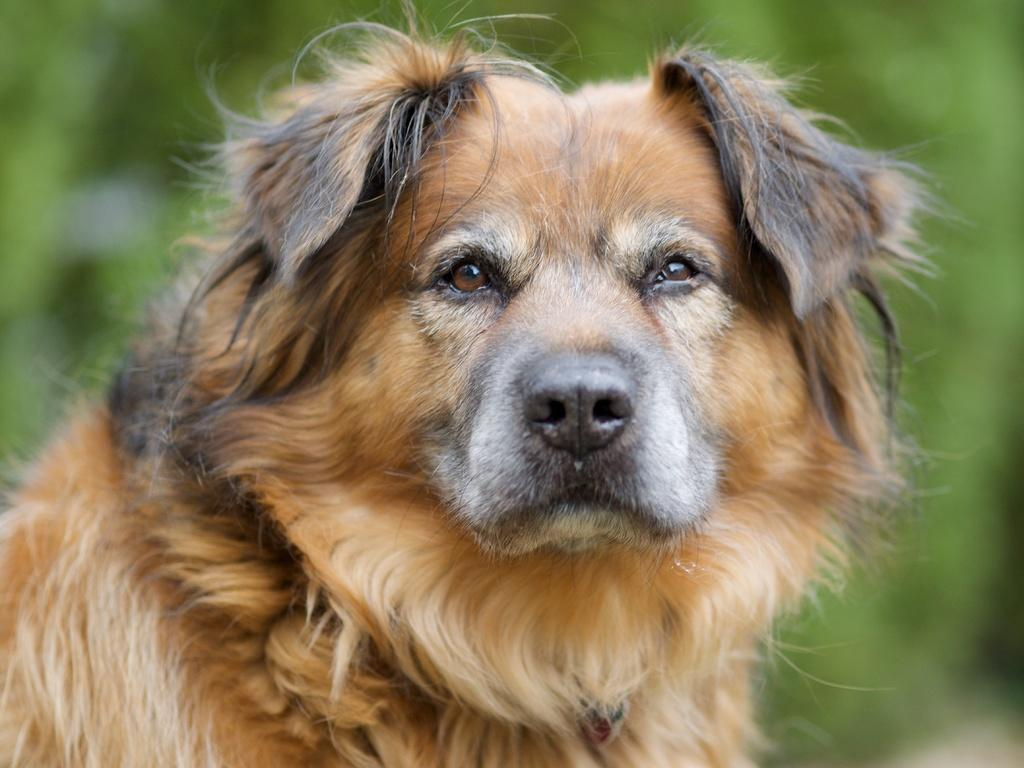What is the main subject in the center of the image? There is a dog in the center of the image. Can you describe the background of the image? The background of the image is blurry. What type of zephyr is present in the image? There is no zephyr present in the image; a zephyr refers to a gentle breeze, and there is no mention of weather or wind in the provided facts. 